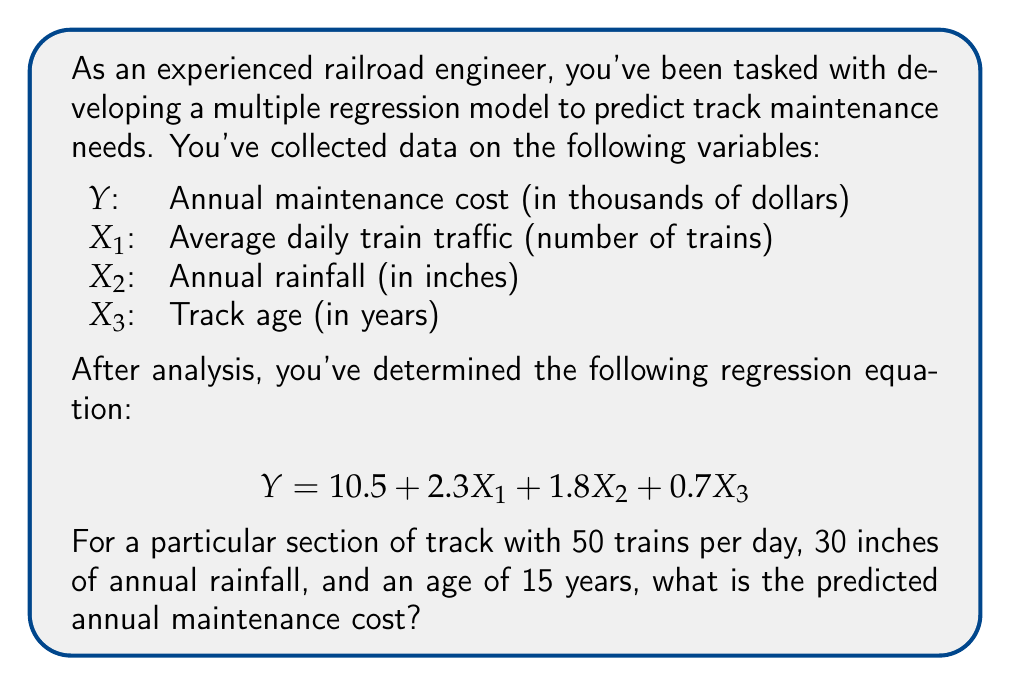Help me with this question. To solve this problem, we'll follow these steps:

1. Identify the given regression equation:
   $$Y = 10.5 + 2.3X_1 + 1.8X_2 + 0.7X_3$$

2. Identify the values for each variable:
   $X_1$ (Average daily train traffic) = 50
   $X_2$ (Annual rainfall) = 30
   $X_3$ (Track age) = 15

3. Substitute these values into the equation:
   $$Y = 10.5 + 2.3(50) + 1.8(30) + 0.7(15)$$

4. Solve the equation:
   $$Y = 10.5 + 115 + 54 + 10.5$$
   $$Y = 190$$

5. Interpret the result:
   The predicted annual maintenance cost is $190,000 (remember that Y was in thousands of dollars).
Answer: $190,000 